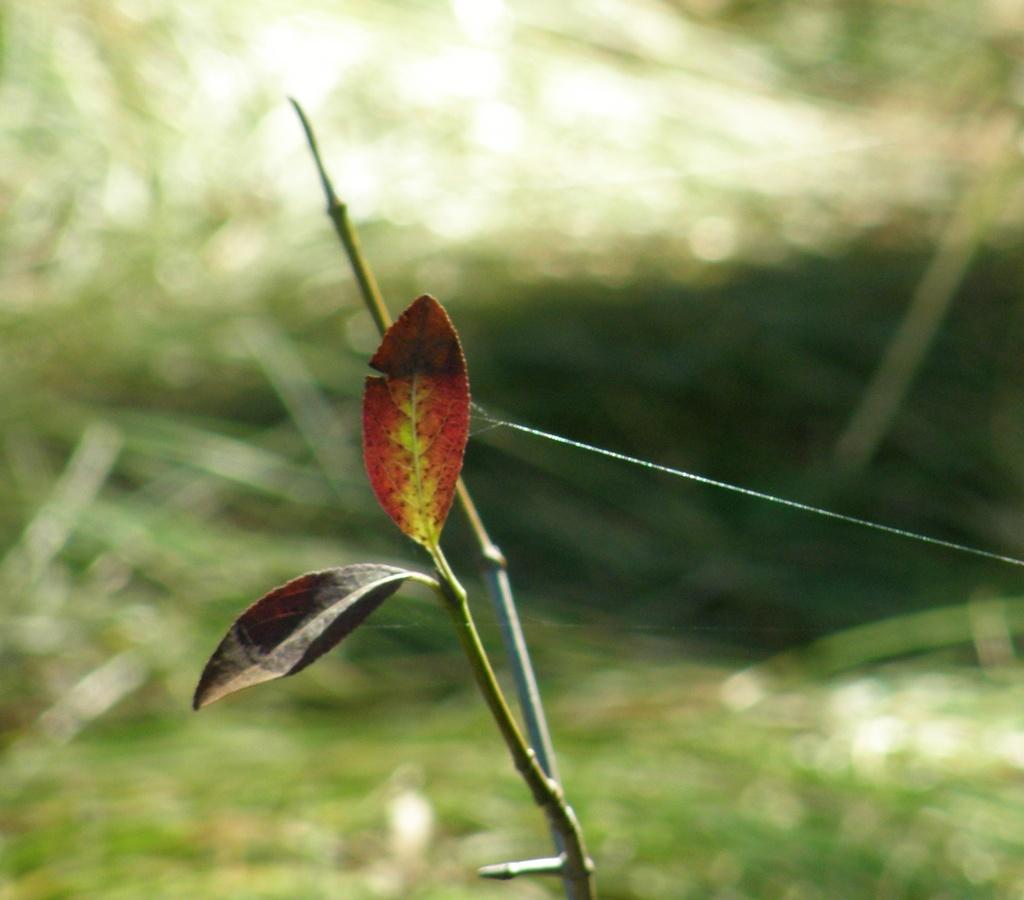What can be seen in the foreground of the image? There are leaves and a stem in the foreground of the image. Can you describe the background of the image? The background of the image is blurry. How many crows are sitting on the leaves in the image? There are no crows present in the image; it only features leaves and a stem. What is the size of the copy of the image? The size of the image cannot be determined from the provided facts, as we are only given information about the contents of the image and not its dimensions. 